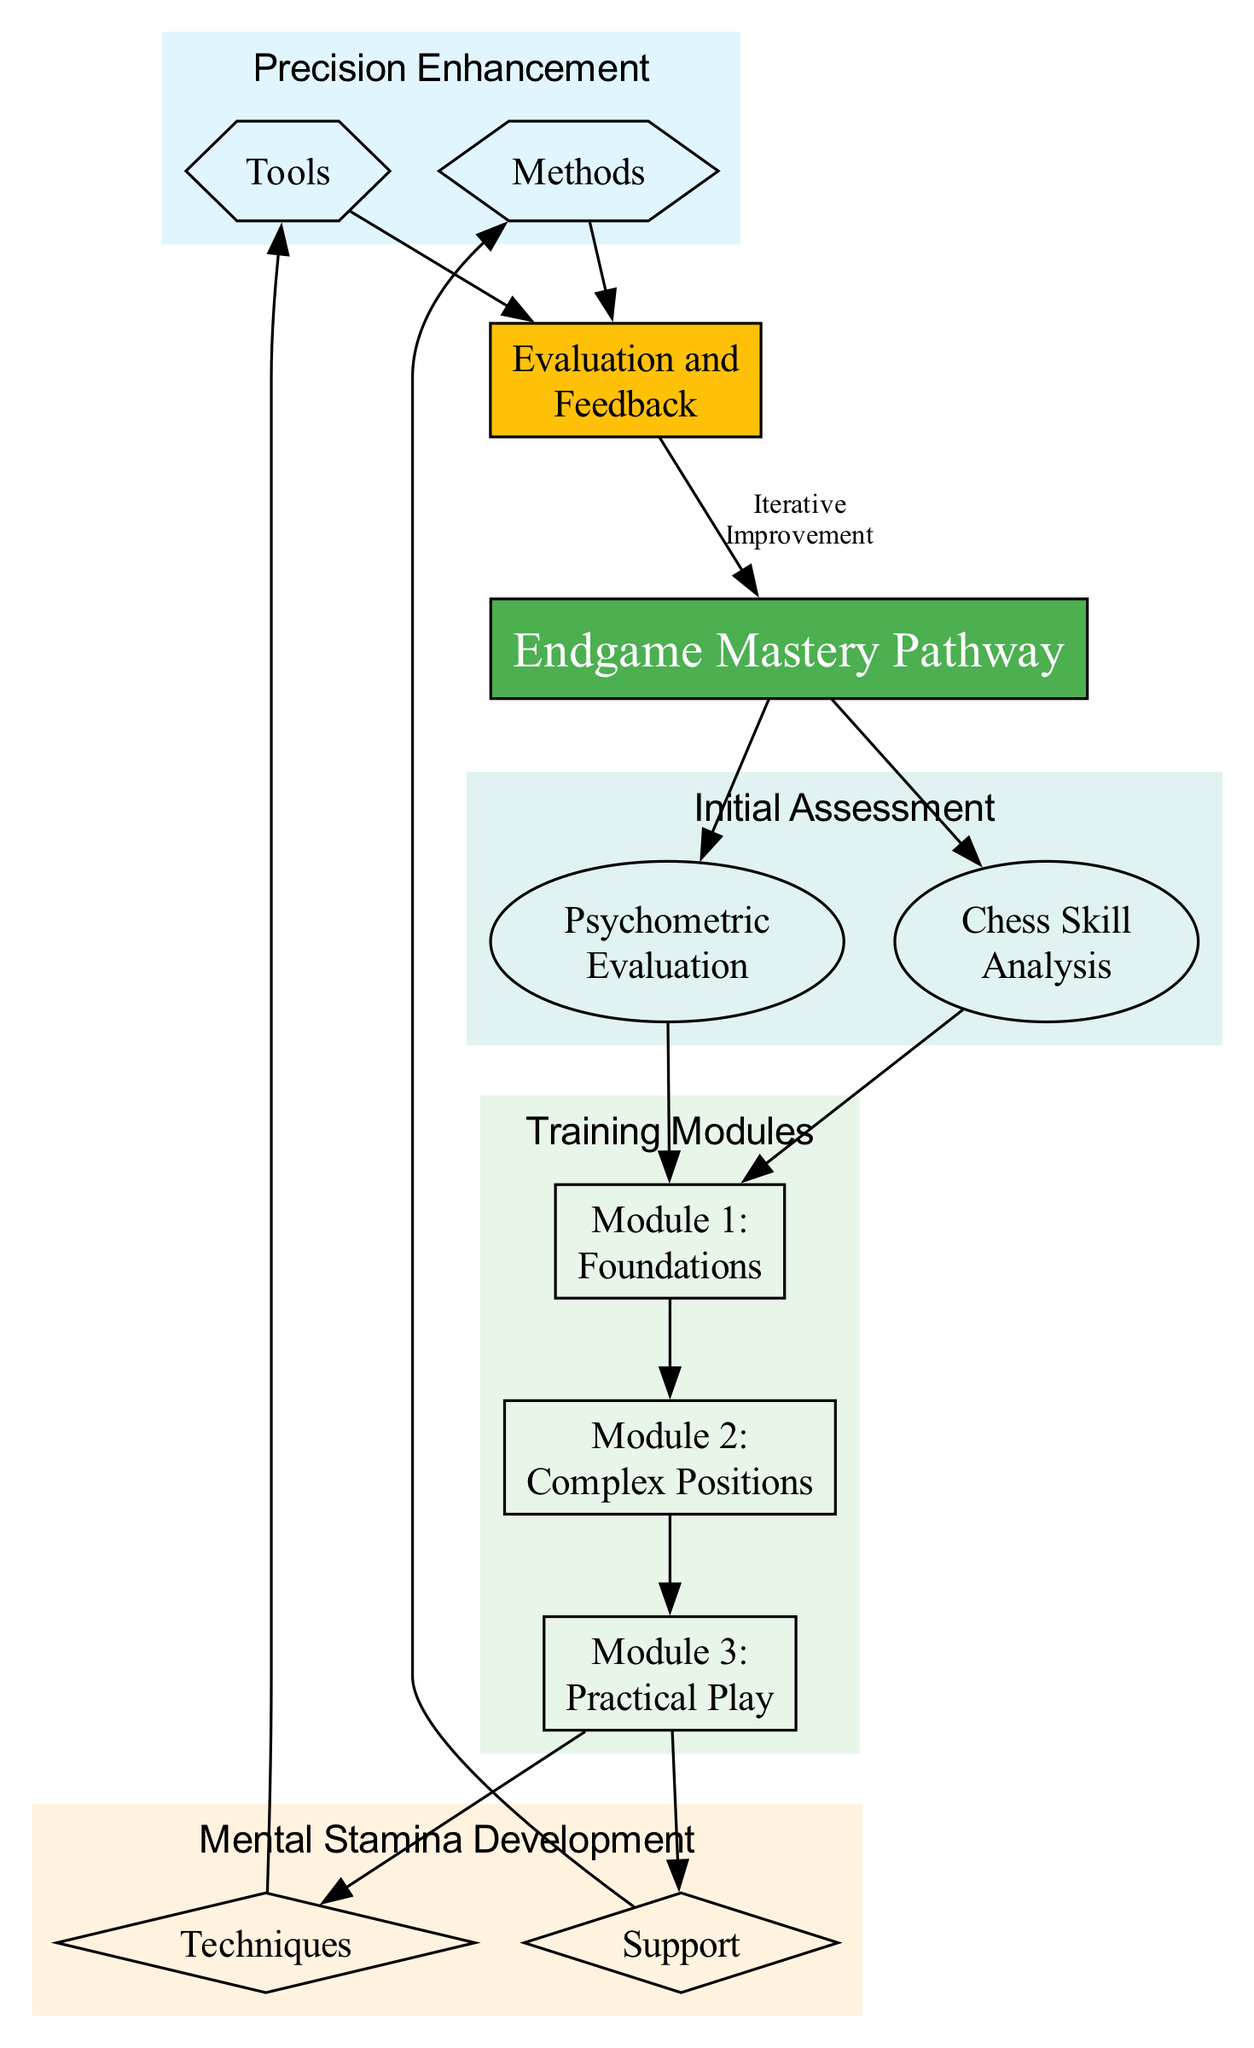What are the two components of the Initial Assessment? The diagram shows that the Initial Assessment has two components, namely "Psychometric Evaluation" and "Chess Skill Analysis". These components are displayed as nodes under the Initial Assessment cluster, indicating their key roles in assessing the player's readiness.
Answer: Psychometric Evaluation, Chess Skill Analysis How many training modules are included in the pathway? The diagram clearly lists three training modules under the "Training Modules" cluster. Each module is marked as a distinct node, confirming that there are three in total: Foundations of Endgame Theory, Complex Endgame Positions, and Practical Endgame Play and Simulation.
Answer: 3 What is the main focus of Module 2? The title of Module 2 is "Complex Endgame Positions", which indicates that its focus is on analyzing and understanding intricate endgame situations typical of high-level matches. This can also be inferred from the node representing the module in the diagram.
Answer: Complex Endgame Positions Which two areas are mentioned under Mental Stamina Development? The diagram specifies two areas under the Mental Stamina Development cluster: "Techniques" and "Support". Both areas are represented as diamond-shaped nodes, showing their importance in developing mental stamina for chess.
Answer: Techniques, Support What is the final step indicated after Evaluation and Feedback? The diagram points to an iterative improvement method that follows the Evaluation and Feedback stage, indicating that the results feed back into the main pathway for continuous enhancement. This connection is indicated by an edge leading back to the "Endgame Mastery Pathway" node.
Answer: Iterative Improvement Which module directly links to the techniques for Mental Stamina Development? The diagram indicates that "Module 3: Practical Endgame Play" directly links to "Techniques" under Mental Stamina Development, showing that the practical training culminates in applying techniques to enhance mental stamina in real game situations.
Answer: Module 3: Practical Endgame Play What are the tools listed for Precision Enhancement? The diagram includes two tools depicted under the Precision Enhancement cluster: "Use of software like Lichess for real-time analysis" and "Engagement in tactical drills targeting endgame moves". These tools focus specifically on improving precision in endgame play.
Answer: Use of software like Lichess, Engagement in tactical drills How is performance tracked according to the diagram? The diagram states that "Performance Tracking" occurs through "Weekly analysis of progress in training modules". This highlights the systematic approach to monitoring improvement over time.
Answer: Weekly analysis of progress in training modules 